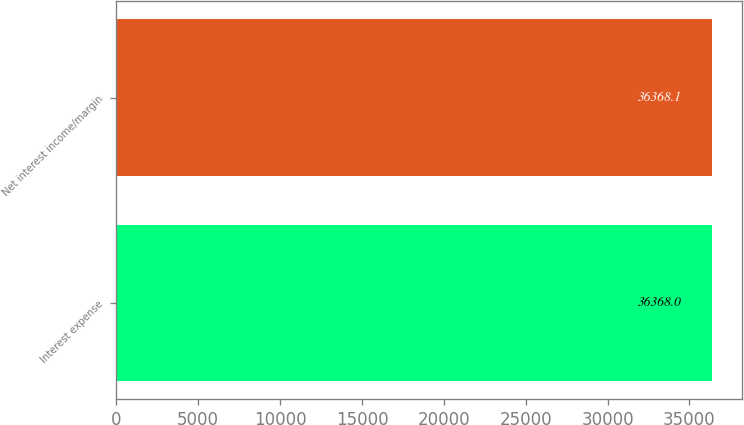<chart> <loc_0><loc_0><loc_500><loc_500><bar_chart><fcel>Interest expense<fcel>Net interest income/margin<nl><fcel>36368<fcel>36368.1<nl></chart> 